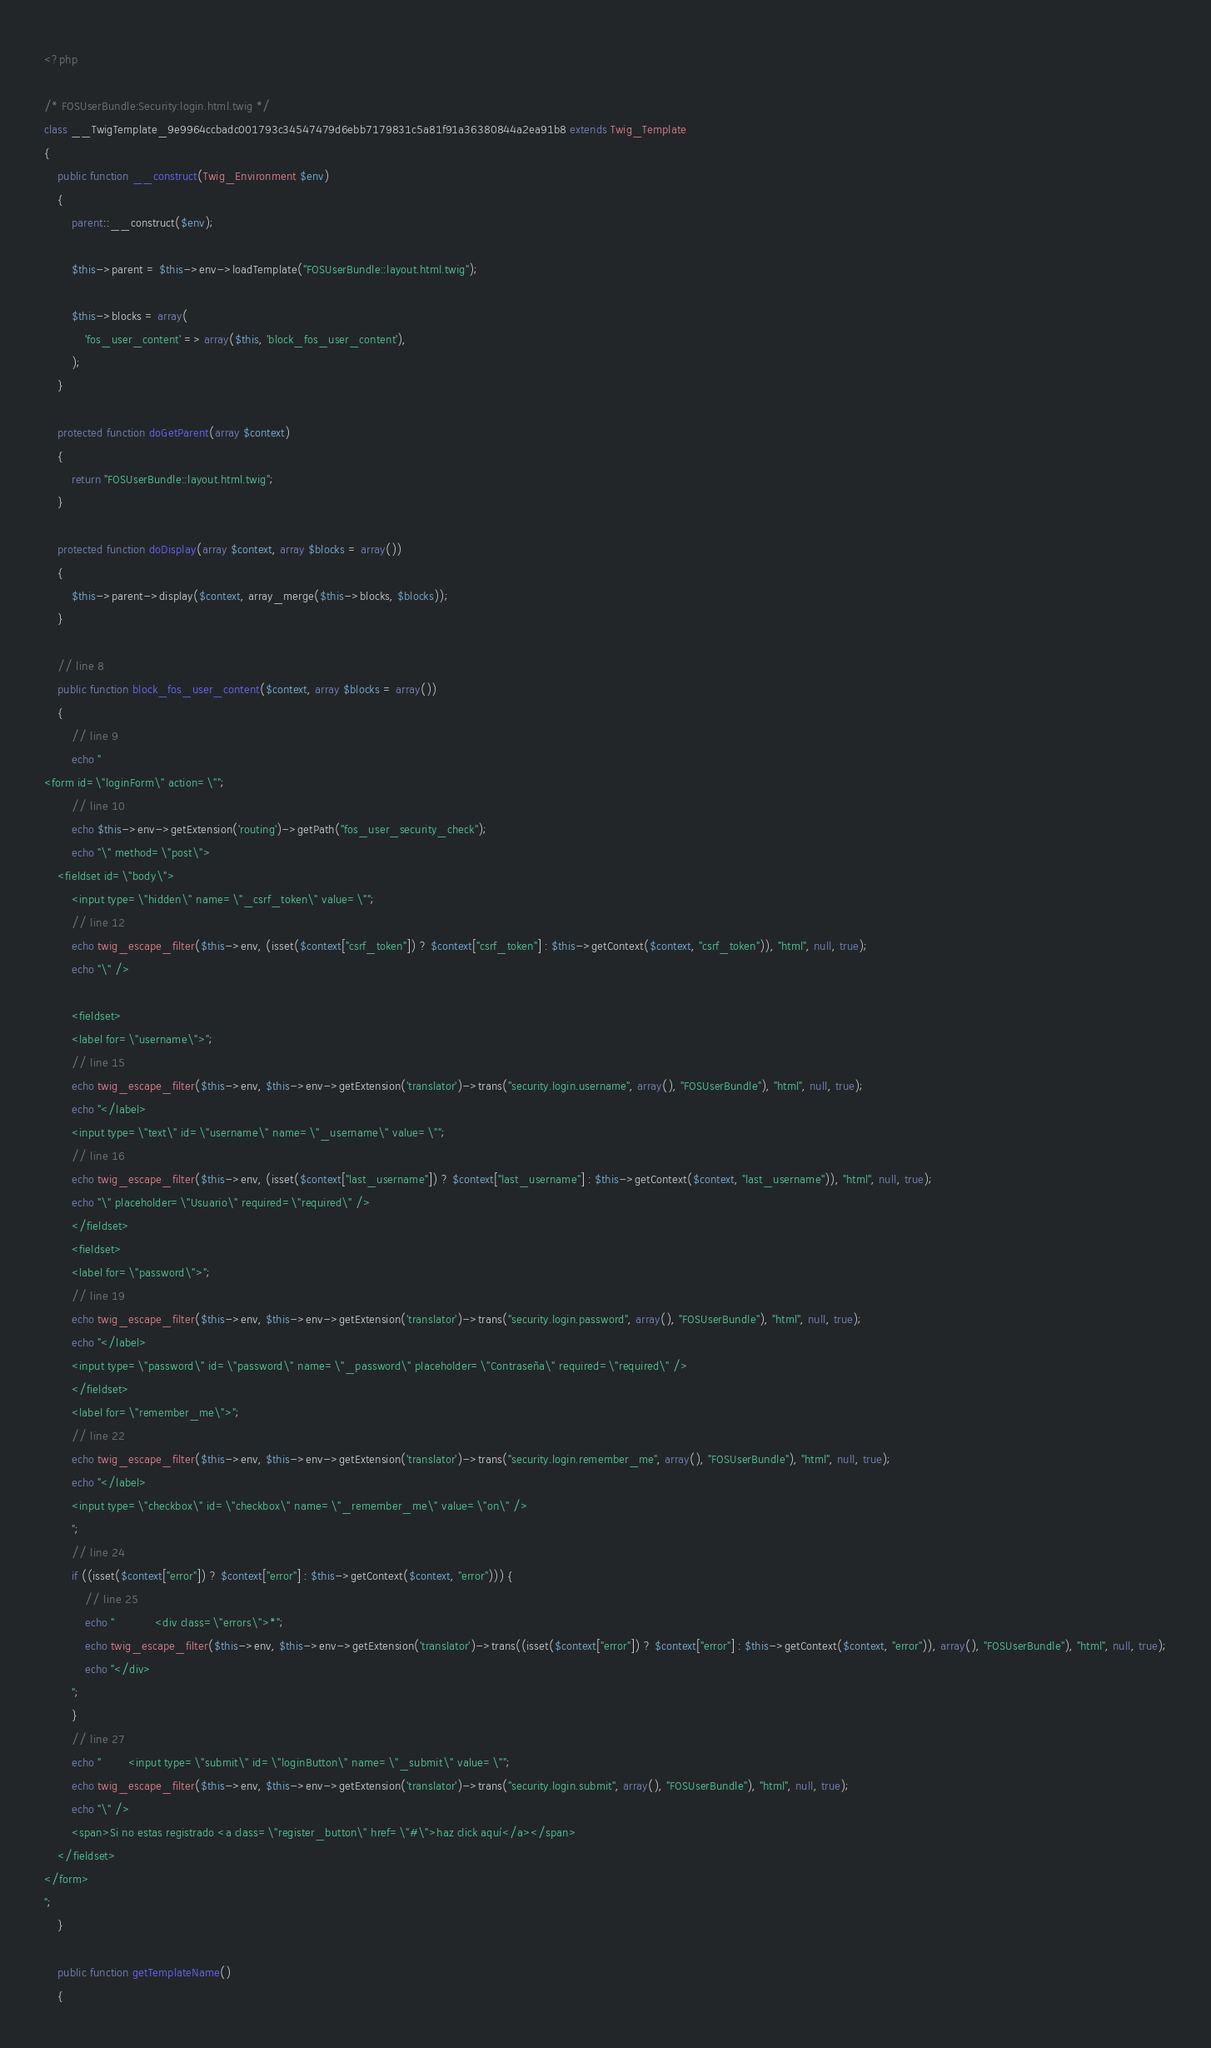Convert code to text. <code><loc_0><loc_0><loc_500><loc_500><_PHP_><?php

/* FOSUserBundle:Security:login.html.twig */
class __TwigTemplate_9e9964ccbadc001793c34547479d6ebb7179831c5a81f91a36380844a2ea91b8 extends Twig_Template
{
    public function __construct(Twig_Environment $env)
    {
        parent::__construct($env);

        $this->parent = $this->env->loadTemplate("FOSUserBundle::layout.html.twig");

        $this->blocks = array(
            'fos_user_content' => array($this, 'block_fos_user_content'),
        );
    }

    protected function doGetParent(array $context)
    {
        return "FOSUserBundle::layout.html.twig";
    }

    protected function doDisplay(array $context, array $blocks = array())
    {
        $this->parent->display($context, array_merge($this->blocks, $blocks));
    }

    // line 8
    public function block_fos_user_content($context, array $blocks = array())
    {
        // line 9
        echo "    
<form id=\"loginForm\" action=\"";
        // line 10
        echo $this->env->getExtension('routing')->getPath("fos_user_security_check");
        echo "\" method=\"post\">
    <fieldset id=\"body\">
        <input type=\"hidden\" name=\"_csrf_token\" value=\"";
        // line 12
        echo twig_escape_filter($this->env, (isset($context["csrf_token"]) ? $context["csrf_token"] : $this->getContext($context, "csrf_token")), "html", null, true);
        echo "\" />
        
        <fieldset>
        <label for=\"username\">";
        // line 15
        echo twig_escape_filter($this->env, $this->env->getExtension('translator')->trans("security.login.username", array(), "FOSUserBundle"), "html", null, true);
        echo "</label>
        <input type=\"text\" id=\"username\" name=\"_username\" value=\"";
        // line 16
        echo twig_escape_filter($this->env, (isset($context["last_username"]) ? $context["last_username"] : $this->getContext($context, "last_username")), "html", null, true);
        echo "\" placeholder=\"Usuario\" required=\"required\" />
        </fieldset>
        <fieldset>
        <label for=\"password\">";
        // line 19
        echo twig_escape_filter($this->env, $this->env->getExtension('translator')->trans("security.login.password", array(), "FOSUserBundle"), "html", null, true);
        echo "</label>
        <input type=\"password\" id=\"password\" name=\"_password\" placeholder=\"Contraseña\" required=\"required\" />
        </fieldset>
        <label for=\"remember_me\">";
        // line 22
        echo twig_escape_filter($this->env, $this->env->getExtension('translator')->trans("security.login.remember_me", array(), "FOSUserBundle"), "html", null, true);
        echo "</label>
        <input type=\"checkbox\" id=\"checkbox\" name=\"_remember_me\" value=\"on\" />
        ";
        // line 24
        if ((isset($context["error"]) ? $context["error"] : $this->getContext($context, "error"))) {
            // line 25
            echo "            <div class=\"errors\">*";
            echo twig_escape_filter($this->env, $this->env->getExtension('translator')->trans((isset($context["error"]) ? $context["error"] : $this->getContext($context, "error")), array(), "FOSUserBundle"), "html", null, true);
            echo "</div>
        ";
        }
        // line 27
        echo "        <input type=\"submit\" id=\"loginButton\" name=\"_submit\" value=\"";
        echo twig_escape_filter($this->env, $this->env->getExtension('translator')->trans("security.login.submit", array(), "FOSUserBundle"), "html", null, true);
        echo "\" />
        <span>Si no estas registrado <a class=\"register_button\" href=\"#\">haz click aquí</a></span>
    </fieldset>
</form>
";
    }

    public function getTemplateName()
    {</code> 